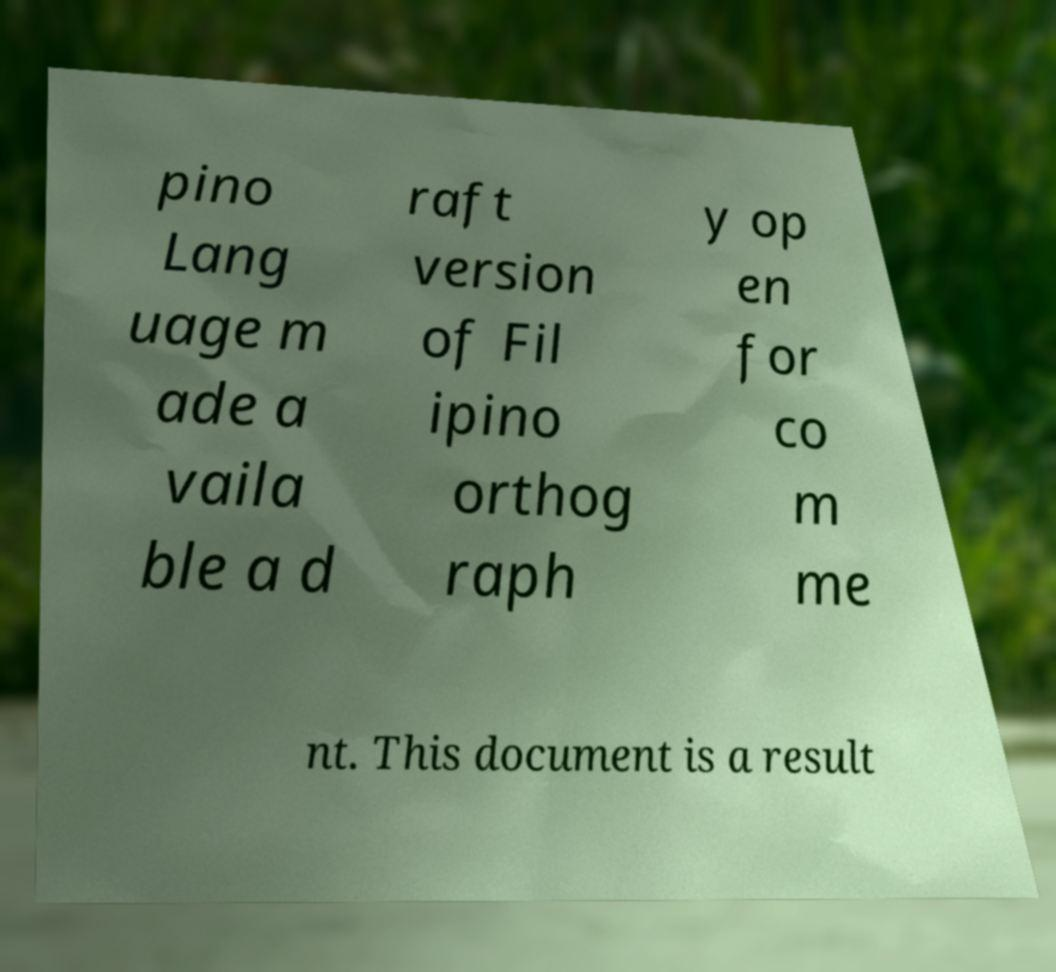Could you assist in decoding the text presented in this image and type it out clearly? pino Lang uage m ade a vaila ble a d raft version of Fil ipino orthog raph y op en for co m me nt. This document is a result 